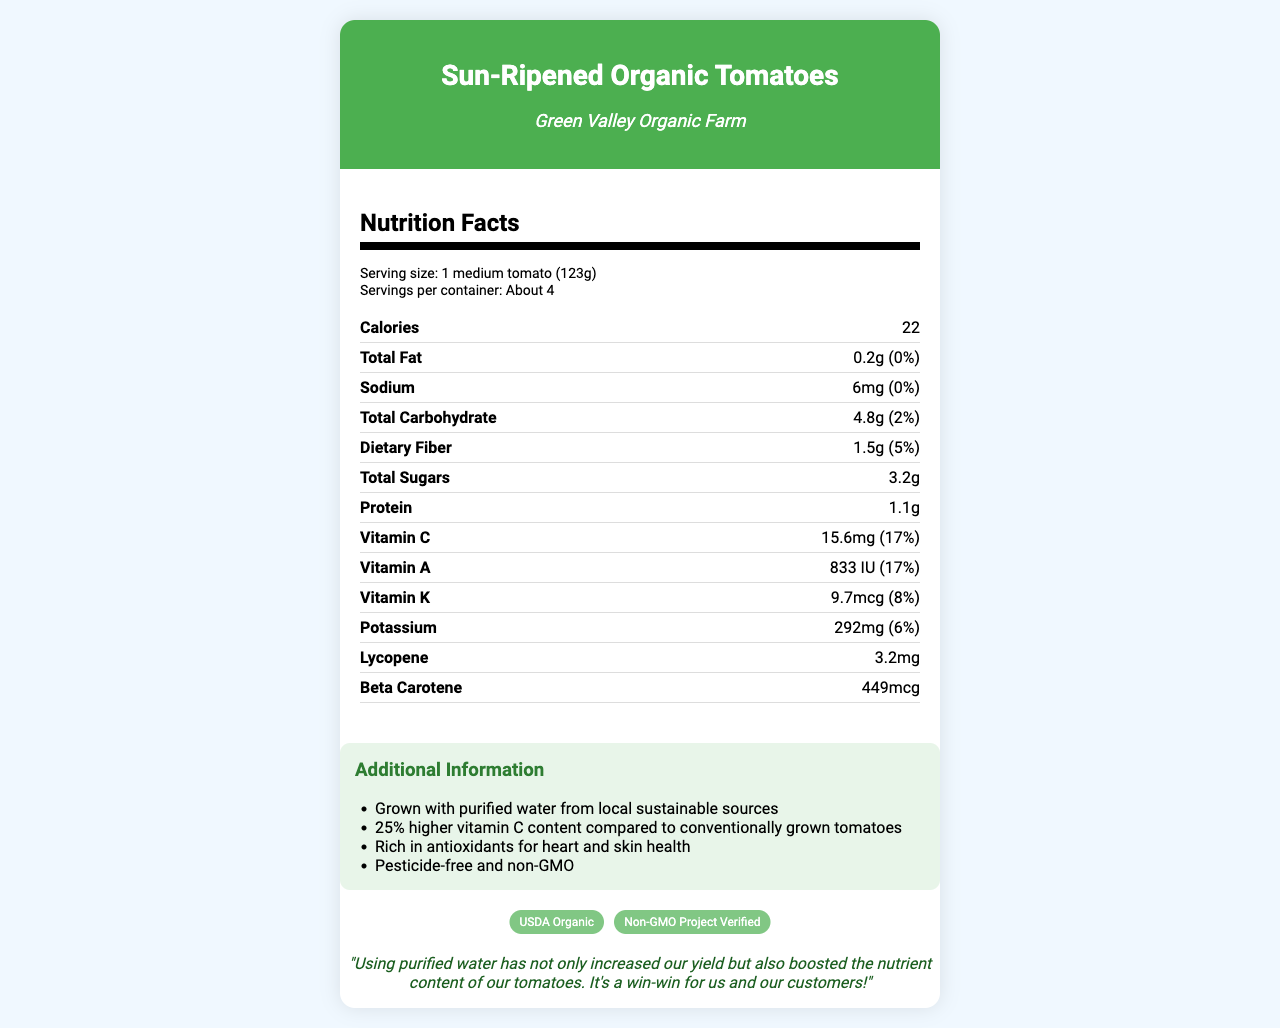how many calories are in one serving? The document states that one medium tomato (123g) contains 22 calories.
Answer: 22 what is the total fat content per serving? The nutrition facts indicate that the total fat content per serving is 0.2g, which is 0% of the daily value.
Answer: 0.2g how many servings are in one container? The document indicates that there are about 4 servings per container.
Answer: About 4 what is the serving size for this product? The serving size listed in the document is one medium tomato, which weighs approximately 123 grams.
Answer: 1 medium tomato (123g) what vitamins are included in the nutrient facts? The document lists Vitamin C, Vitamin A, and Vitamin K under the nutrient facts.
Answer: Vitamin C, Vitamin A, Vitamin K compared to conventionally grown tomatoes, how much higher is the vitamin C content in these organic tomatoes? The additional information mentions that these tomatoes have 25% higher vitamin C content compared to conventionally grown tomatoes.
Answer: 25% higher what is the source of the water used to grow these tomatoes? The additional information section states that locally purified groundwater is used.
Answer: Locally purified groundwater what certifications does the product have? The certifications section lists USDA Organic and Non-GMO Project Verified.
Answer: USDA Organic, Non-GMO Project Verified which nutrient has the highest daily value percentage? A. Vitamin A B. Vitamin C C. Vitamin K Both Vitamin A and Vitamin C have the highest daily value percentage at 17%, but since we need to choose only one option, it is Vitamin A.
Answer: A. Vitamin A what is the potassium content per serving? A. 6mg B. 292mg C. 9.7mcg The document indicates that one serving of the tomatoes contains 292 milligrams of potassium.
Answer: B. 292mg is this product grown with pesticide-free methods? The additional information section notes that the product is pesticide-free.
Answer: Yes summarize the main advantages of this product. This summarizes the various benefits mentioned in the document – increased yield and nutrient content due to purified water, high vitamin C content, certifications, and health benefits.
Answer: The product, Sun-Ripened Organic Tomatoes, is grown with purified water which increases both crop yield and nutrient content, especially vitamin C. It is USDA Organic and Non-GMO Project Verified, pesticide-free, and rich in antioxidants beneficial for heart and skin health. what is the overall daily value percentage of sodium in one serving? The document lists the sodium content as 6mg, which is 0% of the daily value.
Answer: 0% what is the name of the farm that produces these tomatoes? The farm name, Green Valley Organic Farm, is mentioned both in the header and the additional information.
Answer: Green Valley Organic Farm what is the beta carotene content per serving? The beta carotene content listed in the nutrient facts is 449 micrograms.
Answer: 449mcg can you determine the specific antioxidant content from the document? The document mentions that the tomatoes are rich in antioxidants but does not specify which antioxidants other than lycopene and beta carotene.
Answer: Cannot be determined 